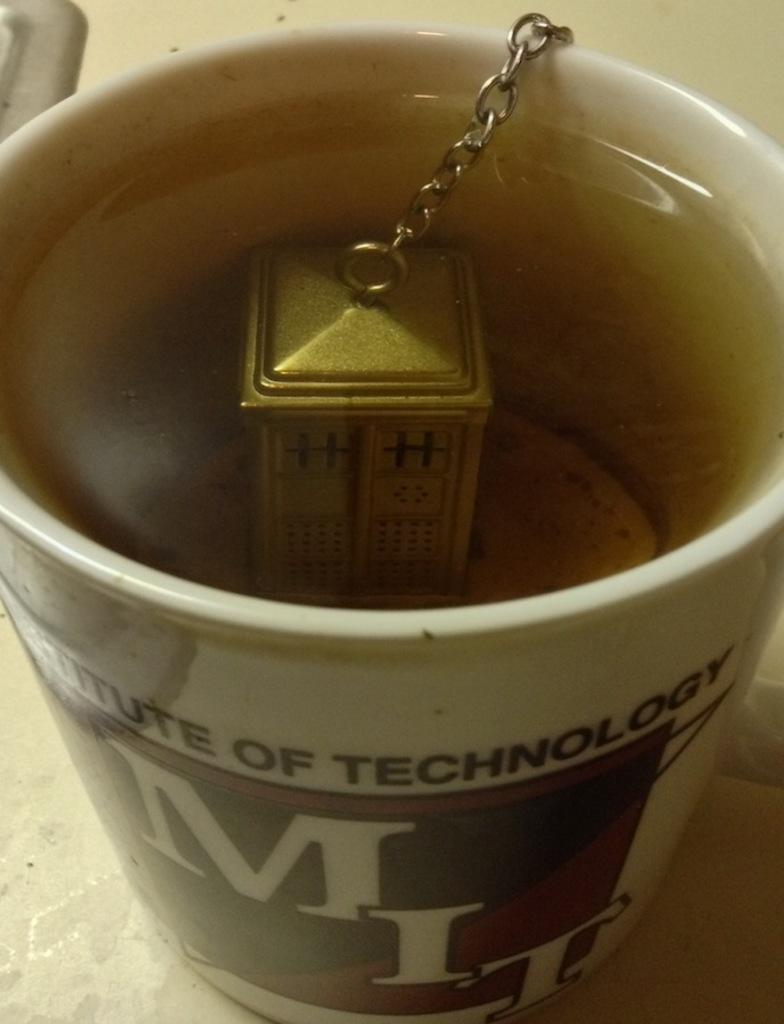<image>
Provide a brief description of the given image. A tea mug with the name Institute of Technology. 